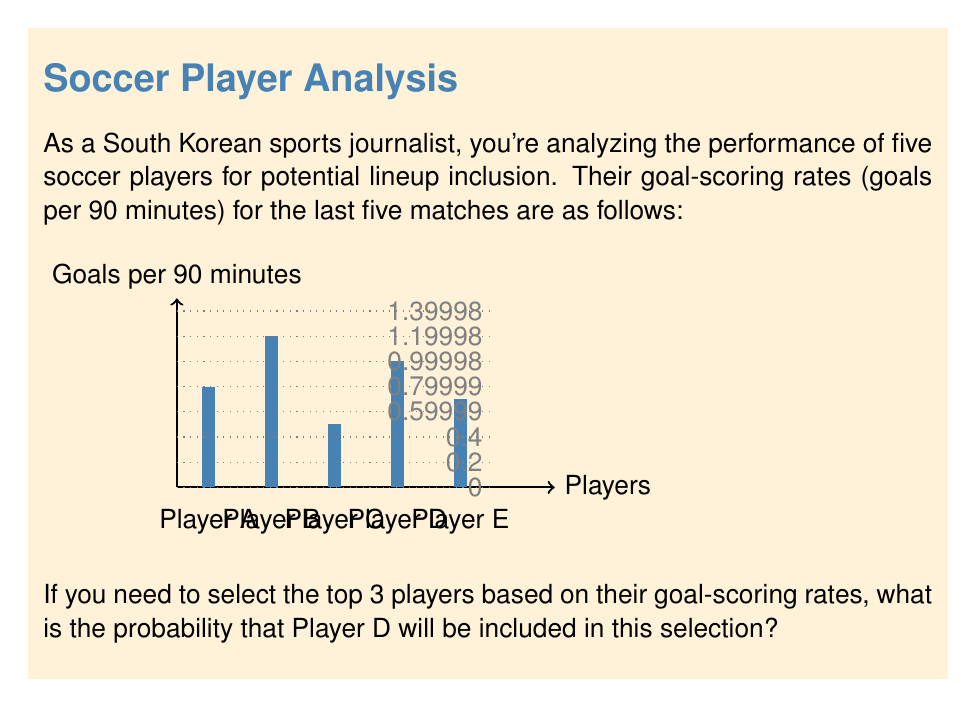Can you answer this question? To solve this problem, we need to follow these steps:

1) First, let's order the players by their goal-scoring rates from highest to lowest:
   Player B: 1.2
   Player D: 1.0
   Player A: 0.8
   Player E: 0.7
   Player C: 0.5

2) Player D will be included in the top 3 if they are ranked 1st, 2nd, or 3rd.

3) To calculate the probability, we need to count the number of favorable outcomes (where Player D is in the top 3) and divide it by the total number of possible outcomes.

4) In this case, Player D is already ranked 2nd, so they will always be in the top 3.

5) The probability can be calculated as:

   $$P(\text{Player D in top 3}) = \frac{\text{Number of ways Player D is in top 3}}{\text{Total number of possible outcomes}}$$

6) Since Player D is always in the top 3:

   $$P(\text{Player D in top 3}) = \frac{1}{1} = 1$$

Therefore, the probability that Player D will be included in the top 3 selection is 1, or 100%.
Answer: 1 